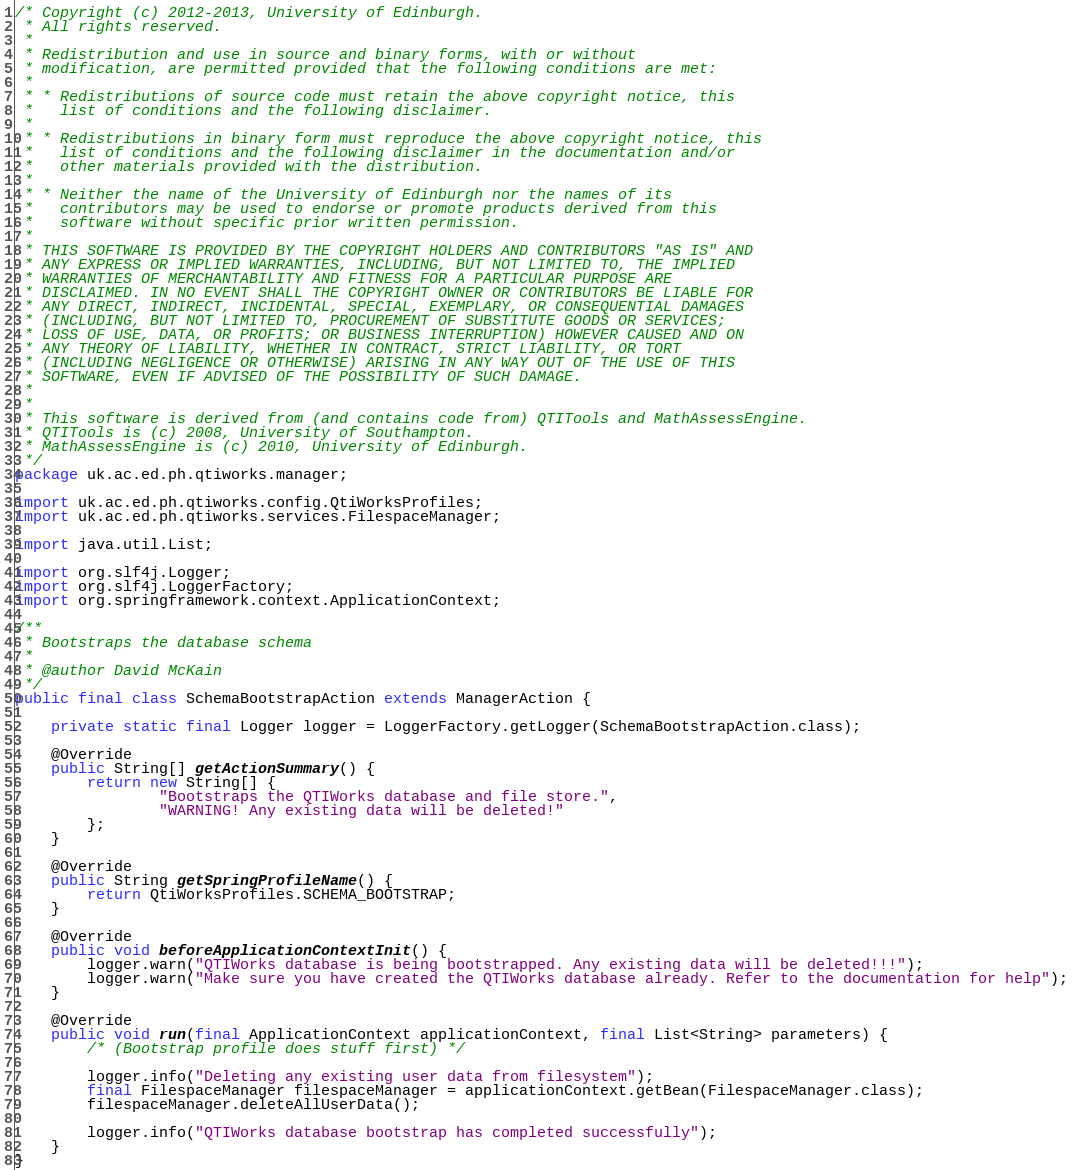Convert code to text. <code><loc_0><loc_0><loc_500><loc_500><_Java_>/* Copyright (c) 2012-2013, University of Edinburgh.
 * All rights reserved.
 *
 * Redistribution and use in source and binary forms, with or without
 * modification, are permitted provided that the following conditions are met:
 *
 * * Redistributions of source code must retain the above copyright notice, this
 *   list of conditions and the following disclaimer.
 *
 * * Redistributions in binary form must reproduce the above copyright notice, this
 *   list of conditions and the following disclaimer in the documentation and/or
 *   other materials provided with the distribution.
 *
 * * Neither the name of the University of Edinburgh nor the names of its
 *   contributors may be used to endorse or promote products derived from this
 *   software without specific prior written permission.
 *
 * THIS SOFTWARE IS PROVIDED BY THE COPYRIGHT HOLDERS AND CONTRIBUTORS "AS IS" AND
 * ANY EXPRESS OR IMPLIED WARRANTIES, INCLUDING, BUT NOT LIMITED TO, THE IMPLIED
 * WARRANTIES OF MERCHANTABILITY AND FITNESS FOR A PARTICULAR PURPOSE ARE
 * DISCLAIMED. IN NO EVENT SHALL THE COPYRIGHT OWNER OR CONTRIBUTORS BE LIABLE FOR
 * ANY DIRECT, INDIRECT, INCIDENTAL, SPECIAL, EXEMPLARY, OR CONSEQUENTIAL DAMAGES
 * (INCLUDING, BUT NOT LIMITED TO, PROCUREMENT OF SUBSTITUTE GOODS OR SERVICES;
 * LOSS OF USE, DATA, OR PROFITS; OR BUSINESS INTERRUPTION) HOWEVER CAUSED AND ON
 * ANY THEORY OF LIABILITY, WHETHER IN CONTRACT, STRICT LIABILITY, OR TORT
 * (INCLUDING NEGLIGENCE OR OTHERWISE) ARISING IN ANY WAY OUT OF THE USE OF THIS
 * SOFTWARE, EVEN IF ADVISED OF THE POSSIBILITY OF SUCH DAMAGE.
 *
 *
 * This software is derived from (and contains code from) QTITools and MathAssessEngine.
 * QTITools is (c) 2008, University of Southampton.
 * MathAssessEngine is (c) 2010, University of Edinburgh.
 */
package uk.ac.ed.ph.qtiworks.manager;

import uk.ac.ed.ph.qtiworks.config.QtiWorksProfiles;
import uk.ac.ed.ph.qtiworks.services.FilespaceManager;

import java.util.List;

import org.slf4j.Logger;
import org.slf4j.LoggerFactory;
import org.springframework.context.ApplicationContext;

/**
 * Bootstraps the database schema
 *
 * @author David McKain
 */
public final class SchemaBootstrapAction extends ManagerAction {

    private static final Logger logger = LoggerFactory.getLogger(SchemaBootstrapAction.class);

    @Override
    public String[] getActionSummary() {
        return new String[] {
                "Bootstraps the QTIWorks database and file store.",
                "WARNING! Any existing data will be deleted!"
        };
    }

    @Override
    public String getSpringProfileName() {
        return QtiWorksProfiles.SCHEMA_BOOTSTRAP;
    }

    @Override
    public void beforeApplicationContextInit() {
        logger.warn("QTIWorks database is being bootstrapped. Any existing data will be deleted!!!");
        logger.warn("Make sure you have created the QTIWorks database already. Refer to the documentation for help");
    }

    @Override
    public void run(final ApplicationContext applicationContext, final List<String> parameters) {
        /* (Bootstrap profile does stuff first) */

        logger.info("Deleting any existing user data from filesystem");
        final FilespaceManager filespaceManager = applicationContext.getBean(FilespaceManager.class);
        filespaceManager.deleteAllUserData();

        logger.info("QTIWorks database bootstrap has completed successfully");
    }
}
</code> 